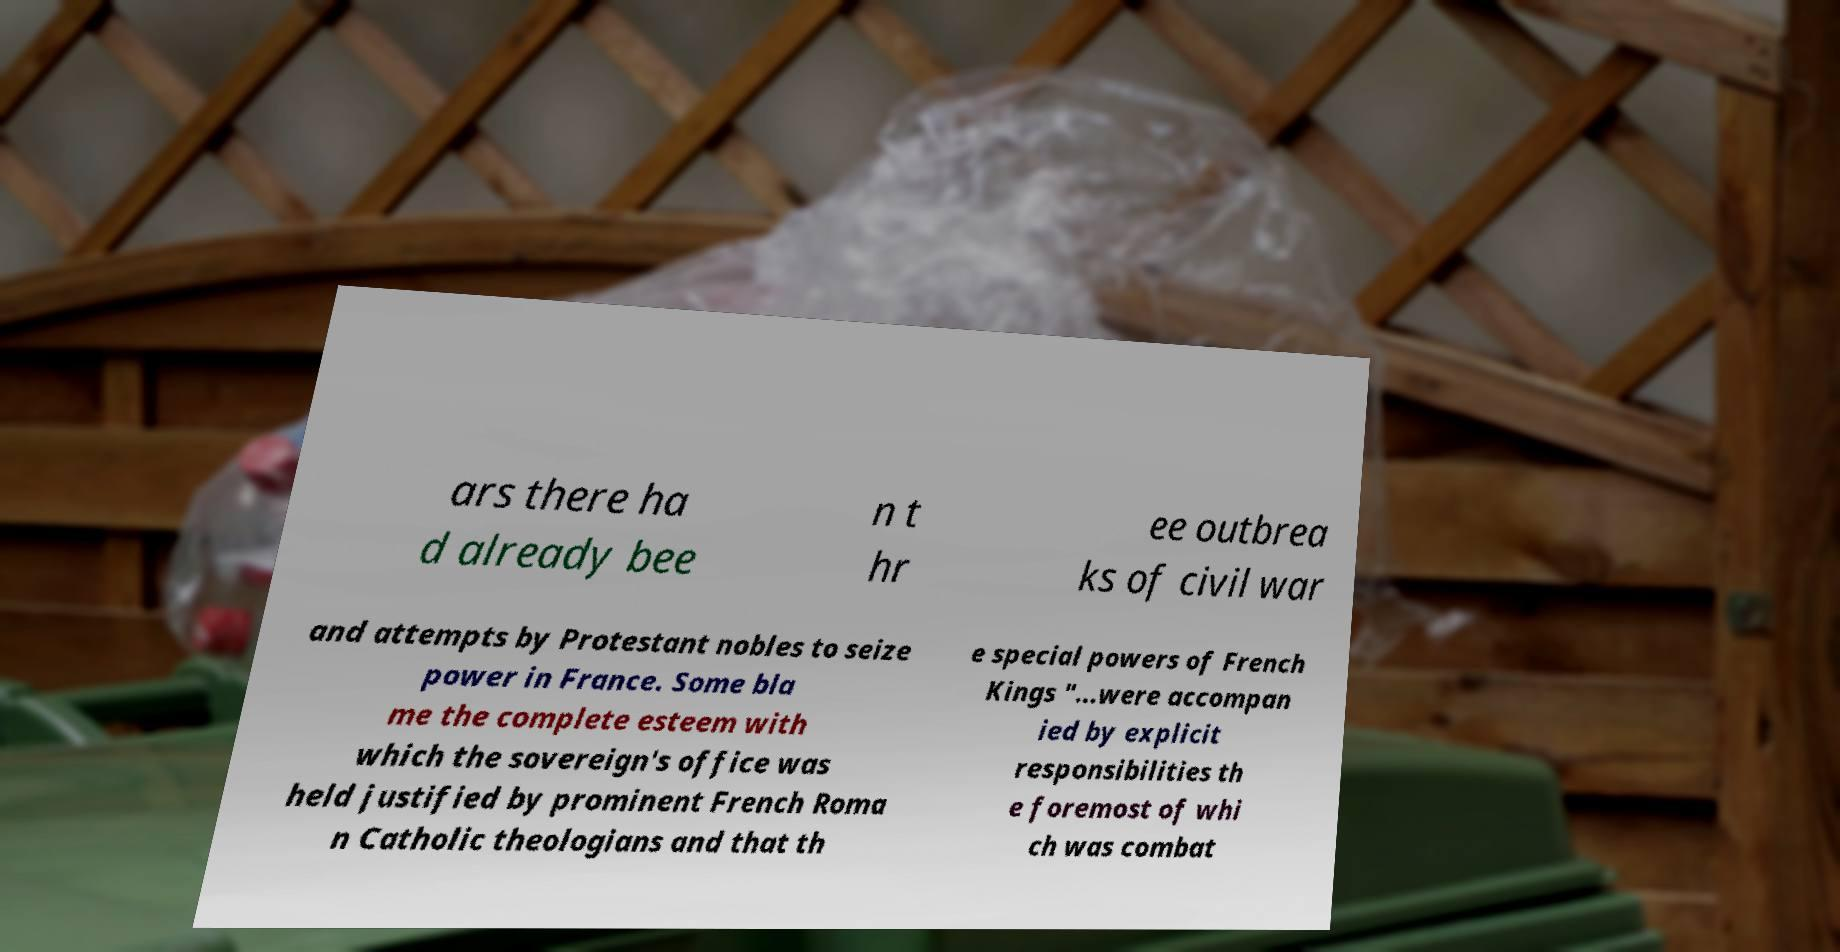I need the written content from this picture converted into text. Can you do that? ars there ha d already bee n t hr ee outbrea ks of civil war and attempts by Protestant nobles to seize power in France. Some bla me the complete esteem with which the sovereign's office was held justified by prominent French Roma n Catholic theologians and that th e special powers of French Kings "...were accompan ied by explicit responsibilities th e foremost of whi ch was combat 